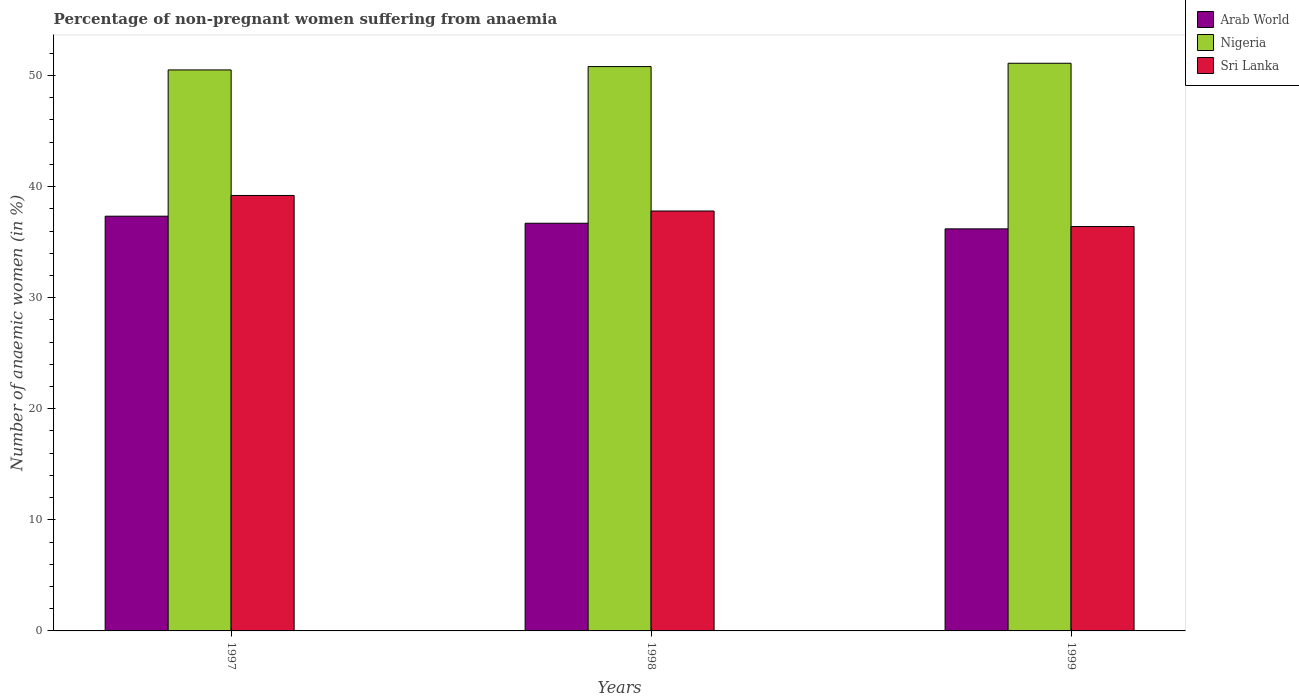How many different coloured bars are there?
Your answer should be very brief. 3. Are the number of bars on each tick of the X-axis equal?
Give a very brief answer. Yes. How many bars are there on the 2nd tick from the left?
Provide a short and direct response. 3. How many bars are there on the 2nd tick from the right?
Offer a very short reply. 3. What is the percentage of non-pregnant women suffering from anaemia in Sri Lanka in 1999?
Offer a terse response. 36.4. Across all years, what is the maximum percentage of non-pregnant women suffering from anaemia in Arab World?
Your answer should be very brief. 37.33. Across all years, what is the minimum percentage of non-pregnant women suffering from anaemia in Sri Lanka?
Your response must be concise. 36.4. What is the total percentage of non-pregnant women suffering from anaemia in Arab World in the graph?
Your answer should be compact. 110.22. What is the difference between the percentage of non-pregnant women suffering from anaemia in Sri Lanka in 1997 and that in 1999?
Your response must be concise. 2.8. What is the difference between the percentage of non-pregnant women suffering from anaemia in Arab World in 1997 and the percentage of non-pregnant women suffering from anaemia in Nigeria in 1999?
Offer a very short reply. -13.77. What is the average percentage of non-pregnant women suffering from anaemia in Sri Lanka per year?
Make the answer very short. 37.8. In the year 1997, what is the difference between the percentage of non-pregnant women suffering from anaemia in Sri Lanka and percentage of non-pregnant women suffering from anaemia in Nigeria?
Provide a succinct answer. -11.3. In how many years, is the percentage of non-pregnant women suffering from anaemia in Arab World greater than 12 %?
Provide a succinct answer. 3. What is the ratio of the percentage of non-pregnant women suffering from anaemia in Nigeria in 1997 to that in 1998?
Your answer should be compact. 0.99. Is the percentage of non-pregnant women suffering from anaemia in Arab World in 1997 less than that in 1998?
Give a very brief answer. No. Is the difference between the percentage of non-pregnant women suffering from anaemia in Sri Lanka in 1997 and 1998 greater than the difference between the percentage of non-pregnant women suffering from anaemia in Nigeria in 1997 and 1998?
Offer a very short reply. Yes. What is the difference between the highest and the second highest percentage of non-pregnant women suffering from anaemia in Sri Lanka?
Provide a succinct answer. 1.4. What is the difference between the highest and the lowest percentage of non-pregnant women suffering from anaemia in Sri Lanka?
Keep it short and to the point. 2.8. In how many years, is the percentage of non-pregnant women suffering from anaemia in Arab World greater than the average percentage of non-pregnant women suffering from anaemia in Arab World taken over all years?
Your response must be concise. 1. What does the 2nd bar from the left in 1998 represents?
Offer a very short reply. Nigeria. What does the 2nd bar from the right in 1999 represents?
Offer a very short reply. Nigeria. Are the values on the major ticks of Y-axis written in scientific E-notation?
Keep it short and to the point. No. Does the graph contain any zero values?
Offer a terse response. No. Does the graph contain grids?
Your answer should be very brief. No. Where does the legend appear in the graph?
Keep it short and to the point. Top right. What is the title of the graph?
Your response must be concise. Percentage of non-pregnant women suffering from anaemia. What is the label or title of the X-axis?
Keep it short and to the point. Years. What is the label or title of the Y-axis?
Give a very brief answer. Number of anaemic women (in %). What is the Number of anaemic women (in %) in Arab World in 1997?
Your answer should be very brief. 37.33. What is the Number of anaemic women (in %) in Nigeria in 1997?
Give a very brief answer. 50.5. What is the Number of anaemic women (in %) of Sri Lanka in 1997?
Offer a terse response. 39.2. What is the Number of anaemic women (in %) of Arab World in 1998?
Provide a short and direct response. 36.7. What is the Number of anaemic women (in %) in Nigeria in 1998?
Your response must be concise. 50.8. What is the Number of anaemic women (in %) of Sri Lanka in 1998?
Ensure brevity in your answer.  37.8. What is the Number of anaemic women (in %) in Arab World in 1999?
Your answer should be compact. 36.19. What is the Number of anaemic women (in %) in Nigeria in 1999?
Make the answer very short. 51.1. What is the Number of anaemic women (in %) in Sri Lanka in 1999?
Your response must be concise. 36.4. Across all years, what is the maximum Number of anaemic women (in %) in Arab World?
Offer a terse response. 37.33. Across all years, what is the maximum Number of anaemic women (in %) in Nigeria?
Offer a terse response. 51.1. Across all years, what is the maximum Number of anaemic women (in %) in Sri Lanka?
Your response must be concise. 39.2. Across all years, what is the minimum Number of anaemic women (in %) of Arab World?
Your response must be concise. 36.19. Across all years, what is the minimum Number of anaemic women (in %) in Nigeria?
Keep it short and to the point. 50.5. Across all years, what is the minimum Number of anaemic women (in %) of Sri Lanka?
Offer a very short reply. 36.4. What is the total Number of anaemic women (in %) in Arab World in the graph?
Make the answer very short. 110.22. What is the total Number of anaemic women (in %) of Nigeria in the graph?
Your answer should be compact. 152.4. What is the total Number of anaemic women (in %) of Sri Lanka in the graph?
Make the answer very short. 113.4. What is the difference between the Number of anaemic women (in %) of Arab World in 1997 and that in 1998?
Your answer should be compact. 0.63. What is the difference between the Number of anaemic women (in %) of Sri Lanka in 1997 and that in 1998?
Offer a very short reply. 1.4. What is the difference between the Number of anaemic women (in %) in Arab World in 1997 and that in 1999?
Keep it short and to the point. 1.14. What is the difference between the Number of anaemic women (in %) of Nigeria in 1997 and that in 1999?
Your answer should be compact. -0.6. What is the difference between the Number of anaemic women (in %) in Arab World in 1998 and that in 1999?
Give a very brief answer. 0.51. What is the difference between the Number of anaemic women (in %) in Arab World in 1997 and the Number of anaemic women (in %) in Nigeria in 1998?
Provide a short and direct response. -13.47. What is the difference between the Number of anaemic women (in %) of Arab World in 1997 and the Number of anaemic women (in %) of Sri Lanka in 1998?
Make the answer very short. -0.47. What is the difference between the Number of anaemic women (in %) in Nigeria in 1997 and the Number of anaemic women (in %) in Sri Lanka in 1998?
Offer a very short reply. 12.7. What is the difference between the Number of anaemic women (in %) of Arab World in 1997 and the Number of anaemic women (in %) of Nigeria in 1999?
Offer a terse response. -13.77. What is the difference between the Number of anaemic women (in %) in Arab World in 1997 and the Number of anaemic women (in %) in Sri Lanka in 1999?
Give a very brief answer. 0.93. What is the difference between the Number of anaemic women (in %) in Arab World in 1998 and the Number of anaemic women (in %) in Nigeria in 1999?
Provide a short and direct response. -14.4. What is the difference between the Number of anaemic women (in %) in Arab World in 1998 and the Number of anaemic women (in %) in Sri Lanka in 1999?
Your response must be concise. 0.3. What is the difference between the Number of anaemic women (in %) in Nigeria in 1998 and the Number of anaemic women (in %) in Sri Lanka in 1999?
Make the answer very short. 14.4. What is the average Number of anaemic women (in %) of Arab World per year?
Ensure brevity in your answer.  36.74. What is the average Number of anaemic women (in %) of Nigeria per year?
Provide a succinct answer. 50.8. What is the average Number of anaemic women (in %) of Sri Lanka per year?
Ensure brevity in your answer.  37.8. In the year 1997, what is the difference between the Number of anaemic women (in %) of Arab World and Number of anaemic women (in %) of Nigeria?
Provide a succinct answer. -13.17. In the year 1997, what is the difference between the Number of anaemic women (in %) of Arab World and Number of anaemic women (in %) of Sri Lanka?
Your answer should be very brief. -1.87. In the year 1997, what is the difference between the Number of anaemic women (in %) of Nigeria and Number of anaemic women (in %) of Sri Lanka?
Offer a terse response. 11.3. In the year 1998, what is the difference between the Number of anaemic women (in %) of Arab World and Number of anaemic women (in %) of Nigeria?
Your answer should be very brief. -14.1. In the year 1998, what is the difference between the Number of anaemic women (in %) in Arab World and Number of anaemic women (in %) in Sri Lanka?
Your response must be concise. -1.1. In the year 1999, what is the difference between the Number of anaemic women (in %) of Arab World and Number of anaemic women (in %) of Nigeria?
Offer a terse response. -14.91. In the year 1999, what is the difference between the Number of anaemic women (in %) of Arab World and Number of anaemic women (in %) of Sri Lanka?
Your answer should be compact. -0.21. In the year 1999, what is the difference between the Number of anaemic women (in %) in Nigeria and Number of anaemic women (in %) in Sri Lanka?
Your answer should be compact. 14.7. What is the ratio of the Number of anaemic women (in %) of Arab World in 1997 to that in 1998?
Offer a very short reply. 1.02. What is the ratio of the Number of anaemic women (in %) of Nigeria in 1997 to that in 1998?
Provide a succinct answer. 0.99. What is the ratio of the Number of anaemic women (in %) in Sri Lanka in 1997 to that in 1998?
Ensure brevity in your answer.  1.04. What is the ratio of the Number of anaemic women (in %) in Arab World in 1997 to that in 1999?
Your response must be concise. 1.03. What is the ratio of the Number of anaemic women (in %) in Nigeria in 1997 to that in 1999?
Provide a succinct answer. 0.99. What is the ratio of the Number of anaemic women (in %) in Arab World in 1998 to that in 1999?
Provide a succinct answer. 1.01. What is the ratio of the Number of anaemic women (in %) of Nigeria in 1998 to that in 1999?
Keep it short and to the point. 0.99. What is the difference between the highest and the second highest Number of anaemic women (in %) in Arab World?
Offer a very short reply. 0.63. What is the difference between the highest and the second highest Number of anaemic women (in %) in Nigeria?
Provide a short and direct response. 0.3. What is the difference between the highest and the lowest Number of anaemic women (in %) of Arab World?
Your answer should be very brief. 1.14. 